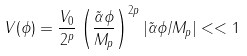Convert formula to latex. <formula><loc_0><loc_0><loc_500><loc_500>V ( \phi ) = { \frac { V _ { 0 } } { 2 ^ { p } } } \left ( \frac { \tilde { \alpha } \phi } { M _ { p } } \right ) ^ { 2 p } | \tilde { \alpha } \phi / M _ { p } | < < 1</formula> 